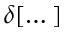<formula> <loc_0><loc_0><loc_500><loc_500>\delta [ \dots ]</formula> 